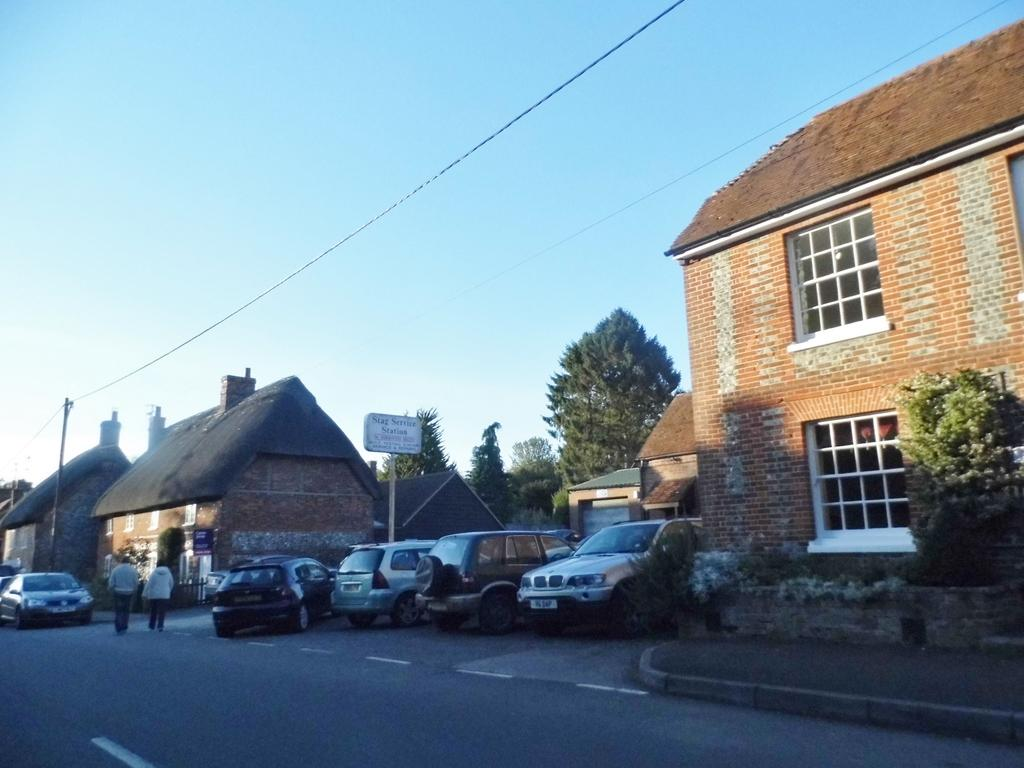What can be seen in the image in terms of transportation? There are many vehicles in the image. What else is happening in the image besides the presence of vehicles? There are people walking in the image. What type of structures are visible in the image? There are houses in the image. What can be seen in the background of the image? There are trees in the image. How would you describe the weather based on the image? The sky is clear in the image, suggesting good weather. Can you tell me how many spoons are being used by the people walking in the image? There is no mention of spoons in the image; people are walking, not using spoons. What type of relationship does the brother have with the people walking in the image? There is no mention of a brother or any specific relationships in the image. 